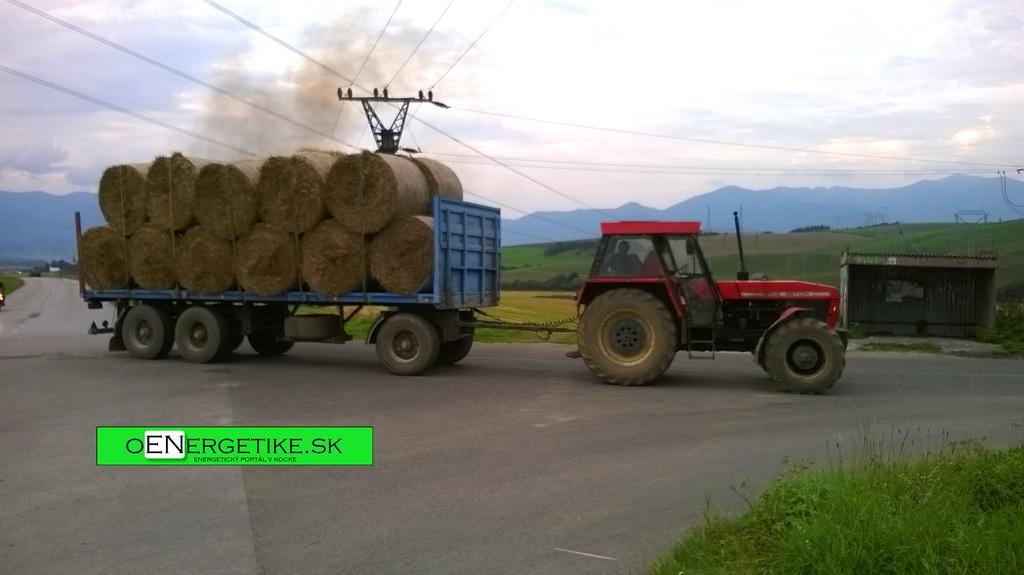Please provide a concise description of this image. In this image there is a truck carrying load, there are towers, an electric pole, cables, a shed, few mountains, birds on the pole, trees and some clouds in the sky. 